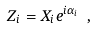Convert formula to latex. <formula><loc_0><loc_0><loc_500><loc_500>Z _ { i } = X _ { i } e ^ { i \alpha _ { i } } \ ,</formula> 